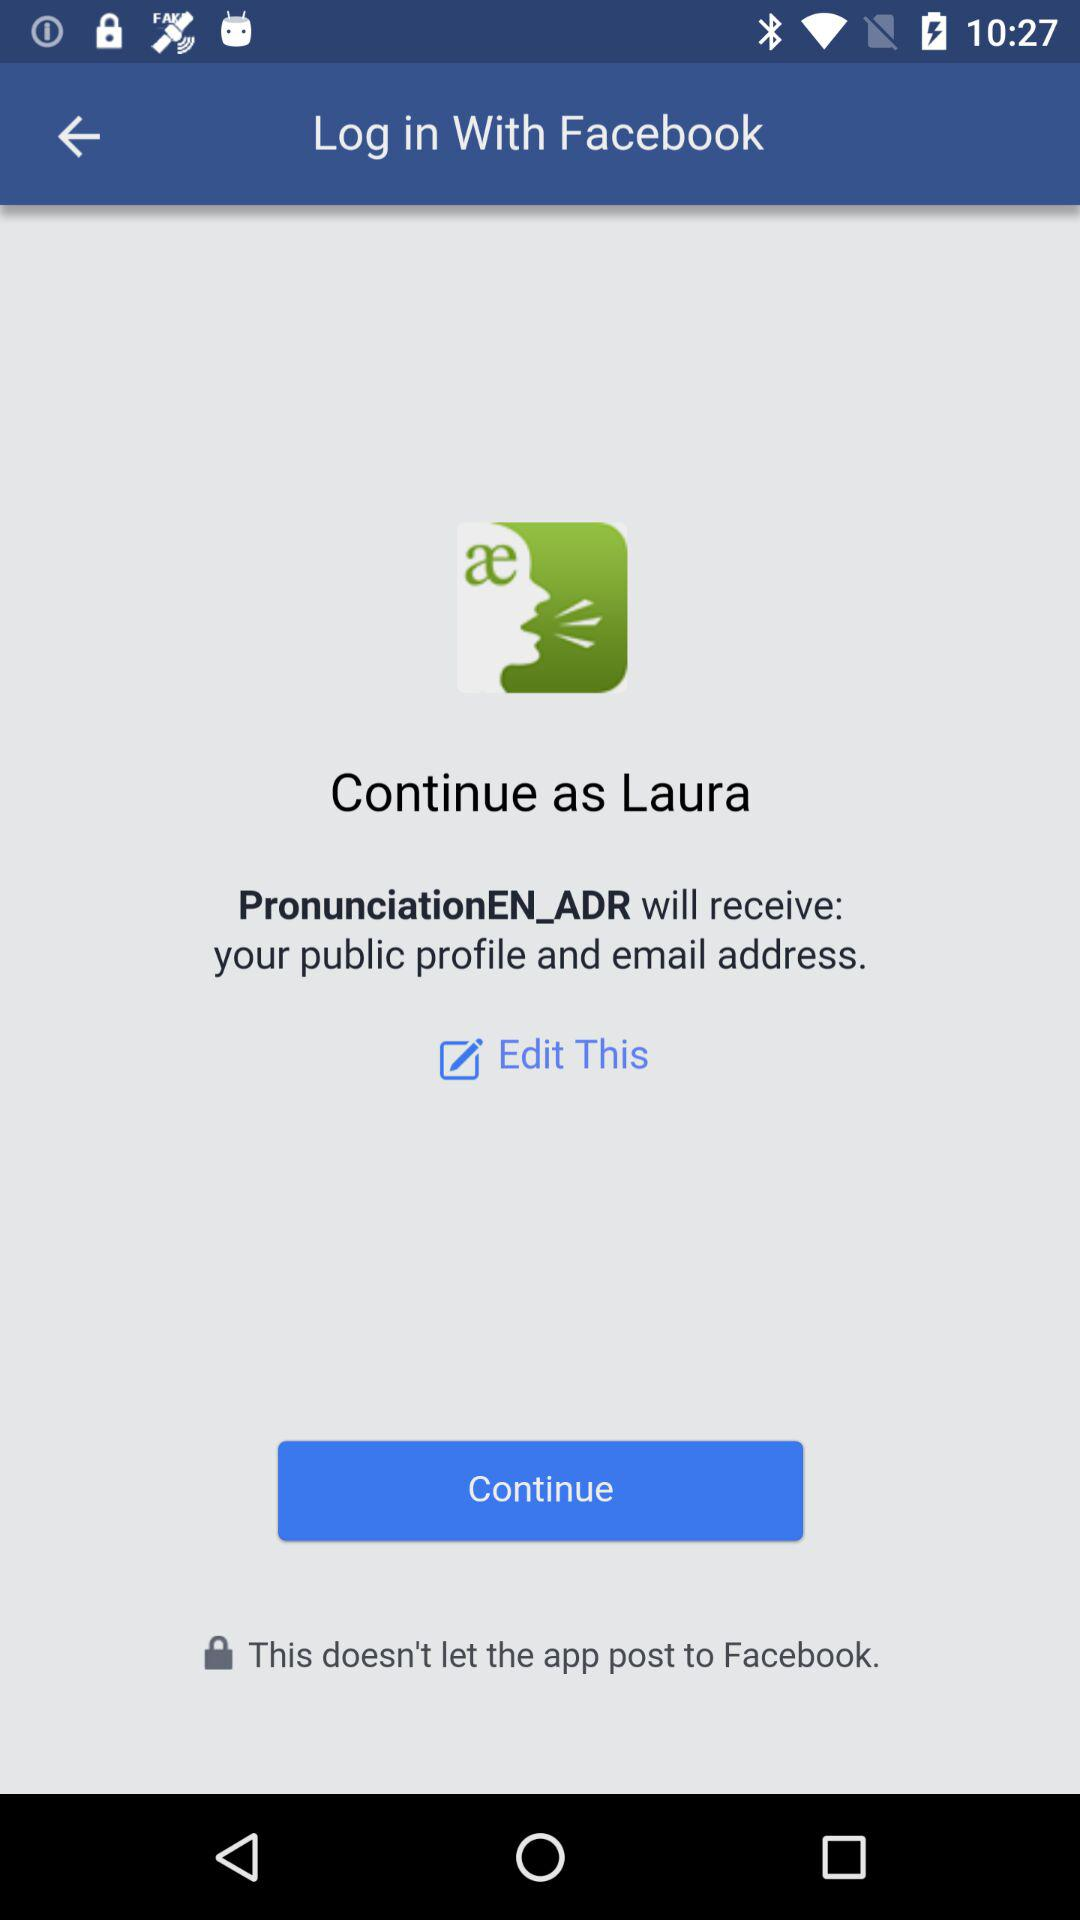Through what application are we logging in? You are logging in through "Facebook". 